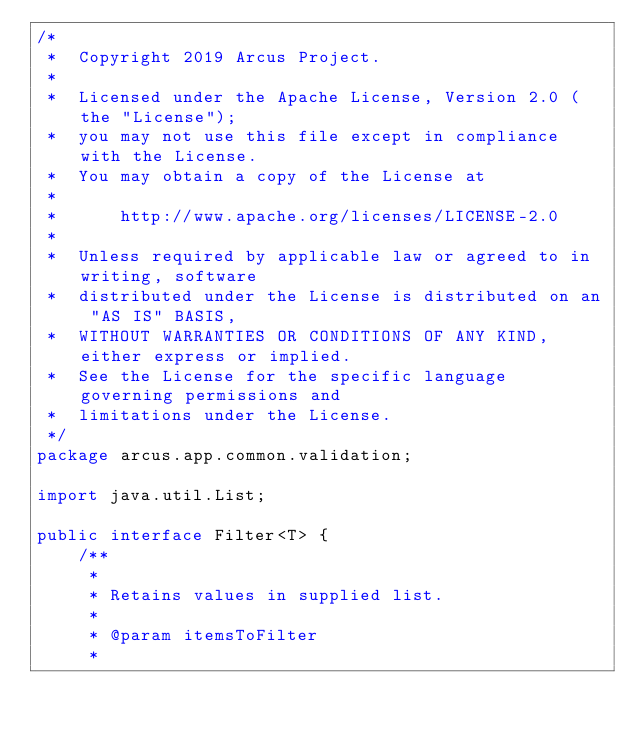<code> <loc_0><loc_0><loc_500><loc_500><_Java_>/*
 *  Copyright 2019 Arcus Project.
 *
 *  Licensed under the Apache License, Version 2.0 (the "License");
 *  you may not use this file except in compliance with the License.
 *  You may obtain a copy of the License at
 *
 *      http://www.apache.org/licenses/LICENSE-2.0
 *
 *  Unless required by applicable law or agreed to in writing, software
 *  distributed under the License is distributed on an "AS IS" BASIS,
 *  WITHOUT WARRANTIES OR CONDITIONS OF ANY KIND, either express or implied.
 *  See the License for the specific language governing permissions and
 *  limitations under the License.
 */
package arcus.app.common.validation;

import java.util.List;

public interface Filter<T> {
    /**
     *
     * Retains values in supplied list.
     *
     * @param itemsToFilter
     *</code> 